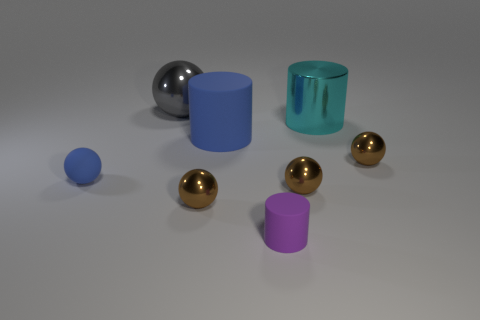Subtract all purple cylinders. How many brown spheres are left? 3 Subtract all blue spheres. How many spheres are left? 4 Subtract all big gray metal spheres. How many spheres are left? 4 Subtract all gray balls. Subtract all brown cylinders. How many balls are left? 4 Add 2 gray shiny objects. How many objects exist? 10 Subtract all cylinders. How many objects are left? 5 Add 7 tiny gray metal blocks. How many tiny gray metal blocks exist? 7 Subtract 1 gray balls. How many objects are left? 7 Subtract all brown matte cylinders. Subtract all brown spheres. How many objects are left? 5 Add 7 tiny blue matte objects. How many tiny blue matte objects are left? 8 